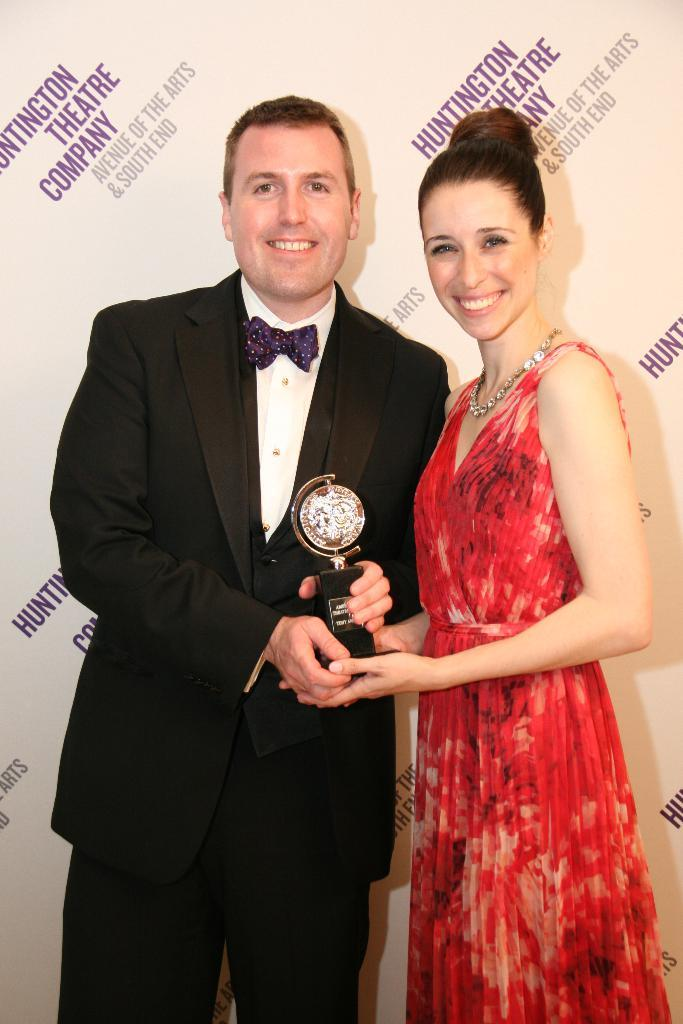Provide a one-sentence caption for the provided image. A couple dressed in formal wearing holding a award standing in front of a poster from the Huntington Theatre Company. 